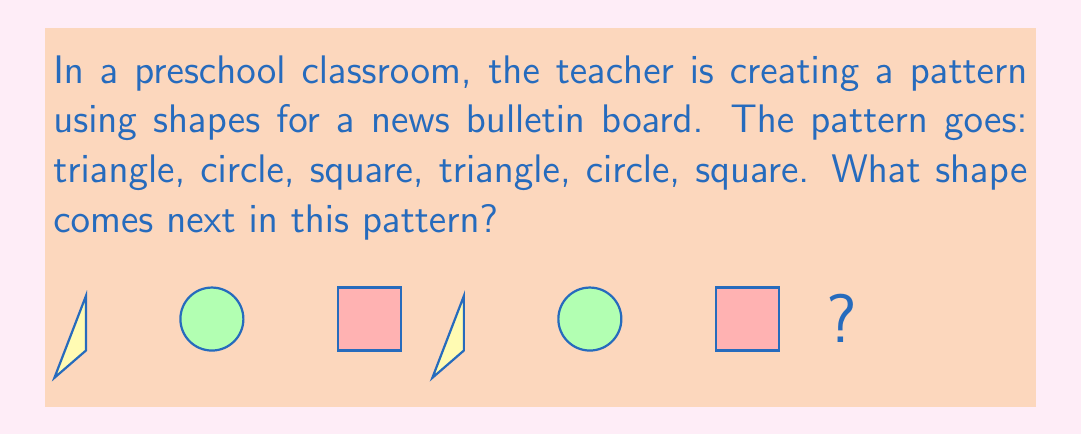Could you help me with this problem? To find the next shape in the pattern, we need to identify the repeating unit and determine where we are in that unit. Let's break it down step-by-step:

1. Identify the repeating unit:
   The pattern is: triangle, circle, square
   This unit repeats twice in the given sequence.

2. Analyze the given sequence:
   triangle, circle, square, triangle, circle, square

3. Identify where we are in the pattern:
   We have completed two full repeating units.

4. Determine the next shape:
   Since we've completed the repeating units, the pattern starts over.
   The first shape in the repeating unit is a triangle.

Therefore, the next shape in the pattern will be a triangle.
Answer: Triangle 